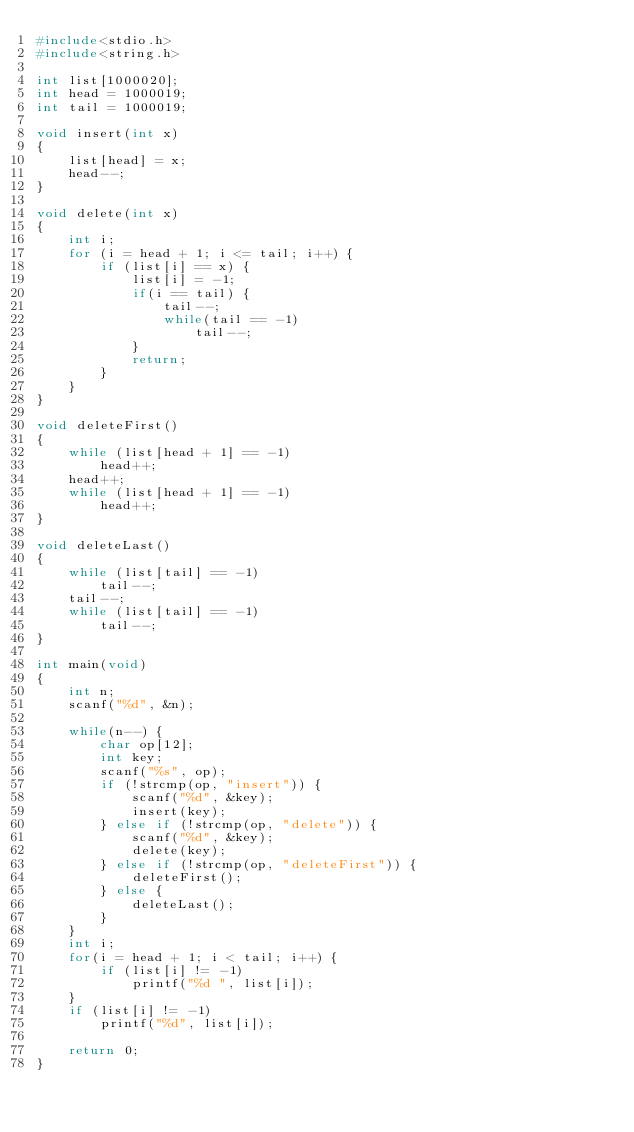Convert code to text. <code><loc_0><loc_0><loc_500><loc_500><_C_>#include<stdio.h>
#include<string.h>

int list[1000020];
int head = 1000019;
int tail = 1000019;

void insert(int x)
{
	list[head] = x;
	head--;
}

void delete(int x)
{
	int i;
	for (i = head + 1; i <= tail; i++) {
		if (list[i] == x) {
			list[i] = -1;
			if(i == tail) {
				tail--;
				while(tail == -1)
					tail--;
			}
			return;
		}
	}
}

void deleteFirst()
{
	while (list[head + 1] == -1)
		head++;
	head++;
	while (list[head + 1] == -1)
		head++;
}

void deleteLast()
{
	while (list[tail] == -1)
		tail--;
	tail--;
	while (list[tail] == -1)
		tail--;
}

int main(void)
{
	int n;
	scanf("%d", &n);
	
	while(n--) {
		char op[12];
		int key;
		scanf("%s", op);
		if (!strcmp(op, "insert")) {
			scanf("%d", &key);
			insert(key);
		} else if (!strcmp(op, "delete")) {
			scanf("%d", &key);
			delete(key);
		} else if (!strcmp(op, "deleteFirst")) {
			deleteFirst();
		} else {
			deleteLast();
		}
	}
	int i;
	for(i = head + 1; i < tail; i++) {
		if (list[i] != -1)
			printf("%d ", list[i]);
	}
	if (list[i] != -1)
		printf("%d", list[i]);
	
	return 0;
}
		
	</code> 